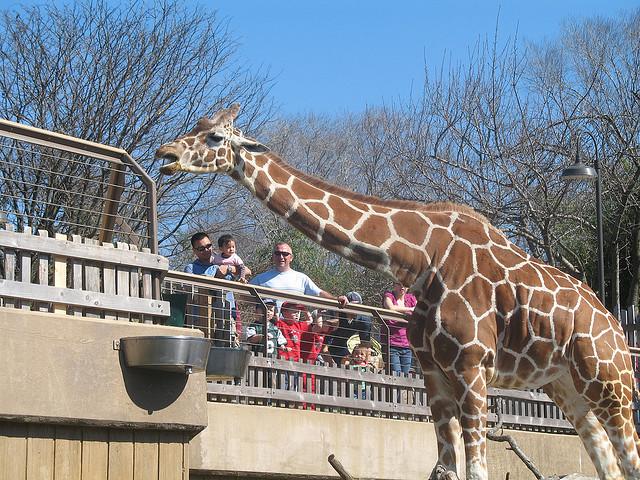What is the giraffe doing?
Be succinct. Eating. How many spots does the giraffe have showing?
Keep it brief. 100. What kind of fencing is in the back?
Answer briefly. Metal. How many children are in this image?
Answer briefly. 4. Where was the picture taken?
Concise answer only. Zoo. 